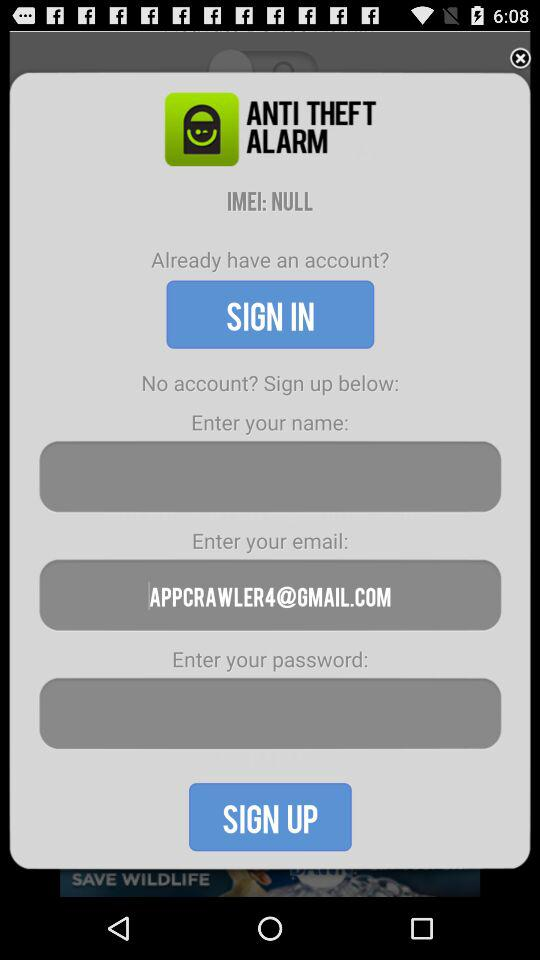What is the email address? The email address is appcrawler4@gmail.com. 